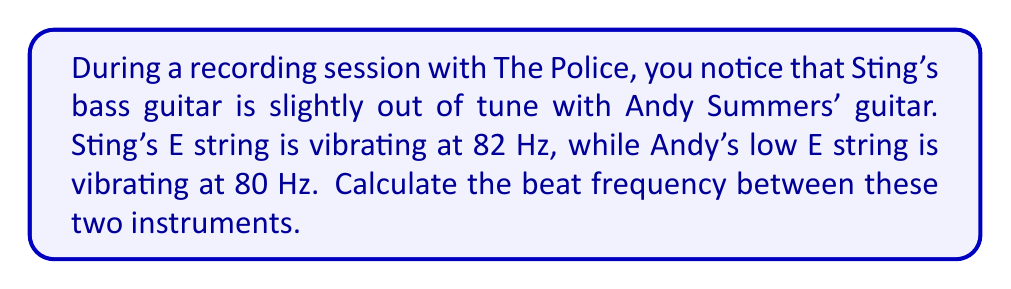Can you solve this math problem? To solve this problem, we need to understand the concept of beat frequency in music and apply it to the given scenario. Let's break it down step-by-step:

1. Beat frequency occurs when two sounds with slightly different frequencies interfere with each other. The resulting sound alternates between loud and soft at a rate equal to the difference between the two frequencies.

2. The formula for beat frequency is:

   $$f_{beat} = |f_1 - f_2|$$

   Where $f_{beat}$ is the beat frequency, and $f_1$ and $f_2$ are the frequencies of the two sounds.

3. In this case:
   $f_1 = 82$ Hz (Sting's bass)
   $f_2 = 80$ Hz (Andy's guitar)

4. Plugging these values into the formula:

   $$f_{beat} = |82 Hz - 80 Hz|$$

5. Simplifying:

   $$f_{beat} = |2 Hz|$$

6. The absolute value of 2 Hz is simply 2 Hz, so:

   $$f_{beat} = 2 Hz$$

This means that the listener will hear a beating sound (alternating loud and soft) twice per second.
Answer: 2 Hz 